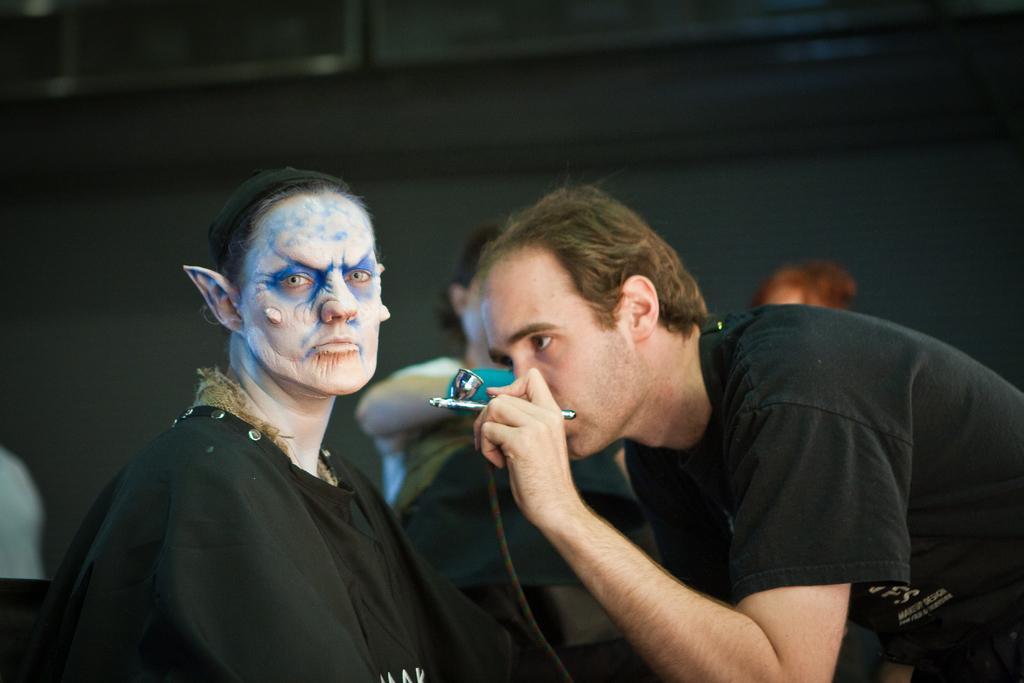In one or two sentences, can you explain what this image depicts? Background portion of the picture is blurry. In this picture we can see the people. On the left side of the picture we can see a person wearing a mask. On the right side of the picture we can see a man holding an object. 